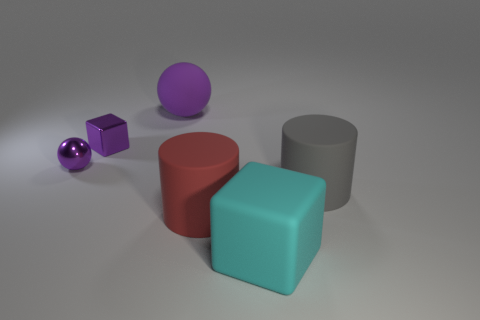There is a rubber object left of the big red cylinder; is it the same size as the cube that is right of the large purple matte sphere?
Keep it short and to the point. Yes. What size is the other metallic object that is the same shape as the cyan object?
Give a very brief answer. Small. Does the shiny ball have the same size as the purple shiny thing that is on the right side of the tiny purple ball?
Keep it short and to the point. Yes. Are there any things that are in front of the matte cylinder that is left of the gray cylinder?
Offer a very short reply. Yes. There is a big rubber object to the right of the cyan block; what shape is it?
Provide a succinct answer. Cylinder. What is the material of the tiny block that is the same color as the big sphere?
Your response must be concise. Metal. The shiny thing that is in front of the small purple thing on the right side of the small purple metallic sphere is what color?
Provide a short and direct response. Purple. Is the size of the matte sphere the same as the red rubber object?
Provide a succinct answer. Yes. There is another object that is the same shape as the big red thing; what is its material?
Your answer should be very brief. Rubber. What number of cubes have the same size as the cyan rubber thing?
Offer a very short reply. 0. 